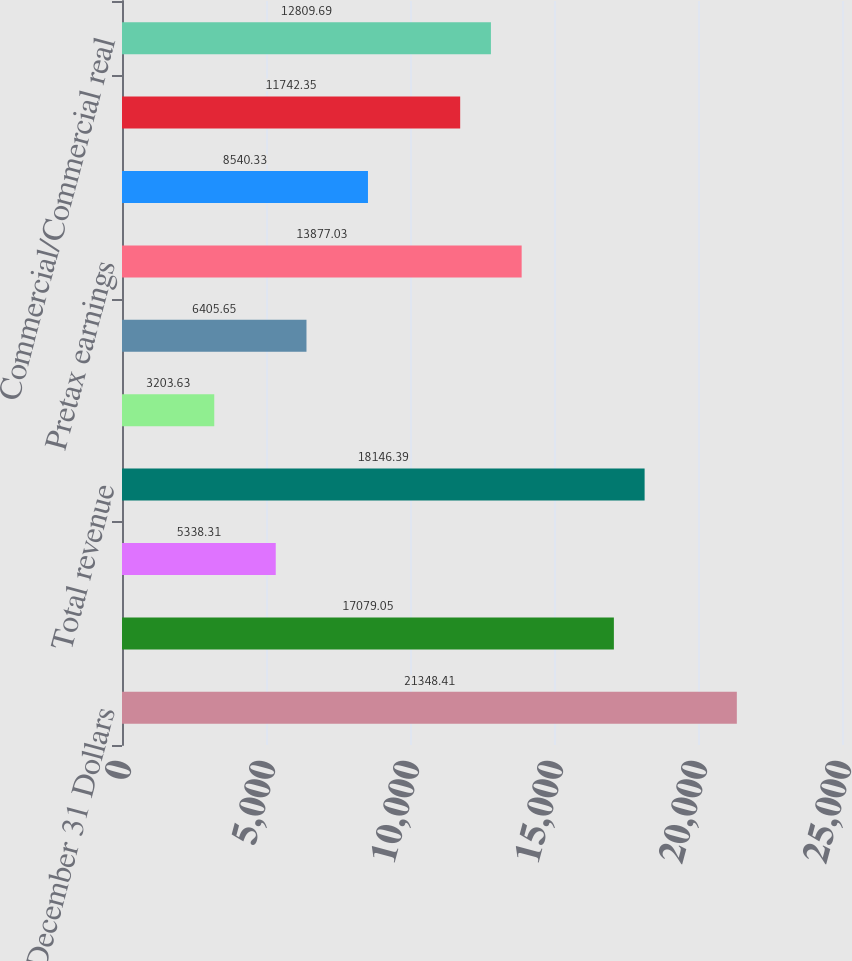Convert chart. <chart><loc_0><loc_0><loc_500><loc_500><bar_chart><fcel>Year ended December 31 Dollars<fcel>Net interest income<fcel>Noninterest income<fcel>Total revenue<fcel>Provision for credit losses<fcel>Noninterest expense<fcel>Pretax earnings<fcel>Income taxes<fcel>Earnings<fcel>Commercial/Commercial real<nl><fcel>21348.4<fcel>17079<fcel>5338.31<fcel>18146.4<fcel>3203.63<fcel>6405.65<fcel>13877<fcel>8540.33<fcel>11742.4<fcel>12809.7<nl></chart> 